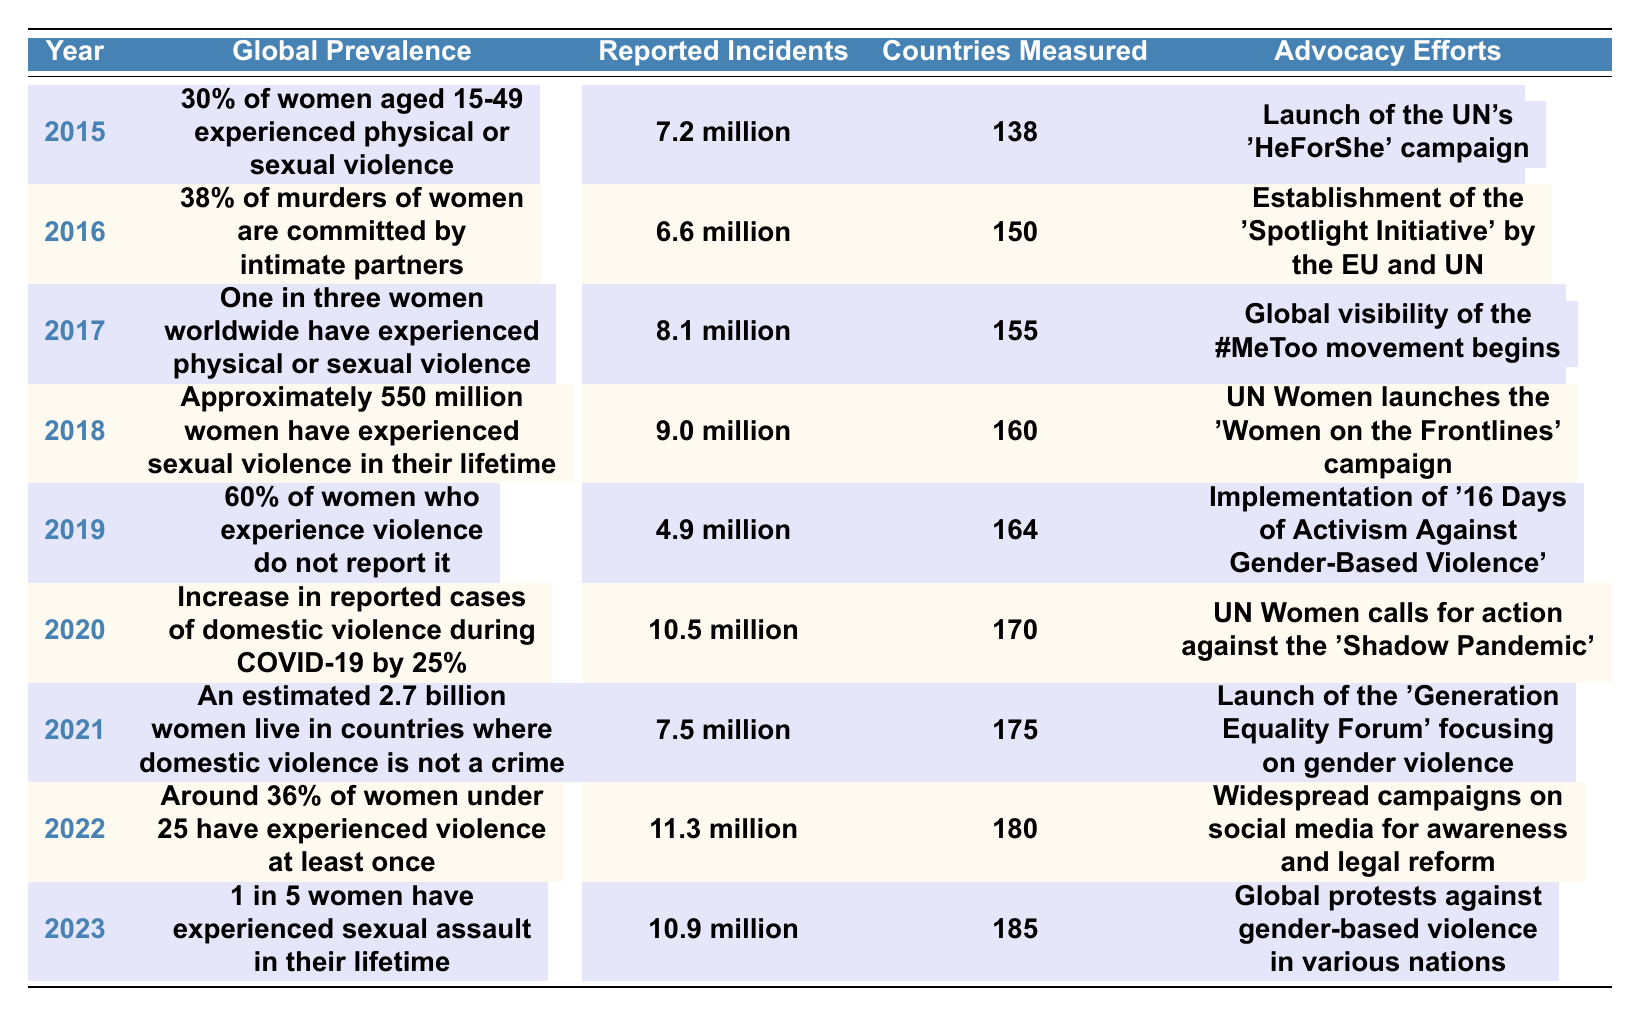What was the global prevalence of violence against women in 2020? The table indicates that in 2020, there was an increase in reported cases of domestic violence during COVID-19. However, it doesn't state a percentage; thus, the specific global prevalence for that year isn't listed directly.
Answer: Not directly stated How many countries were measured for gender-based violence in 2018? According to the table, 160 countries were measured for gender-based violence in 2018. This is a specific retrieval question.
Answer: 160 What was the total number of reported incidents of gender-based violence from 2015 to 2019? To find the total, sum the reported incidents: 7.2 million (2015) + 6.6 million (2016) + 8.1 million (2017) + 9.0 million (2018) + 4.9 million (2019) = 36.8 million.
Answer: 36.8 million Which year saw the highest number of reported incidents of gender-based violence? Looking at the reported incidents listed each year, 2022 had the highest reported incidents at 11.3 million.
Answer: 2022 In which year was the 'Shadow Pandemic' campaign launched? The table shows that the campaign against the 'Shadow Pandemic' launched in 2020 as part of the advocacy efforts.
Answer: 2020 Is it true that more than half of the reported incidents in 2021 were due to domestic violence? The table does not provide specific data indicating the proportion of domestic violence to total incidents reported in 2021. Hence, this cannot be concluded.
Answer: No What was the percentage of women under 25 who have experienced violence at least once, according to the latest year in the table? In 2022, the table states that around 36% of women under 25 have experienced violence at least once.
Answer: 36% How did the reported incidents of gender-based violence change from 2019 to 2020? Comparing the reported incidents: in 2019 it was 4.9 million, and in 2020 it increased to 10.5 million, indicating a rise of 5.6 million incidents.
Answer: Increased by 5.6 million What advocacy effort was launched in 2021 focusing on gender violence? The table shows that in 2021, the 'Generation Equality Forum' was launched focusing on gender violence as its advocacy effort.
Answer: 'Generation Equality Forum' What can be inferred about the trend of reported incidents from 2015 to 2023? By examining the data, it shows a fluctuating trend, with an overall increase in reported incidents over the years. Notably, the figures rose significantly during the COVID-19 pandemic in 2020.
Answer: Overall increasing trend 